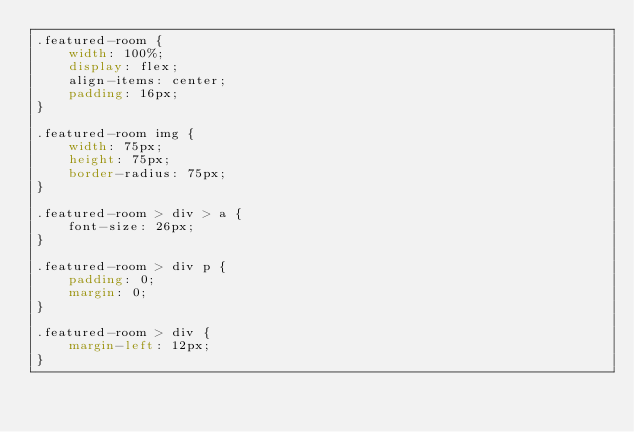<code> <loc_0><loc_0><loc_500><loc_500><_CSS_>.featured-room {
    width: 100%;
    display: flex;
    align-items: center;
    padding: 16px;
}

.featured-room img {
    width: 75px;
    height: 75px;
    border-radius: 75px;
}

.featured-room > div > a {
    font-size: 26px;
}

.featured-room > div p {
    padding: 0;
    margin: 0;
}

.featured-room > div {
    margin-left: 12px;
}
</code> 